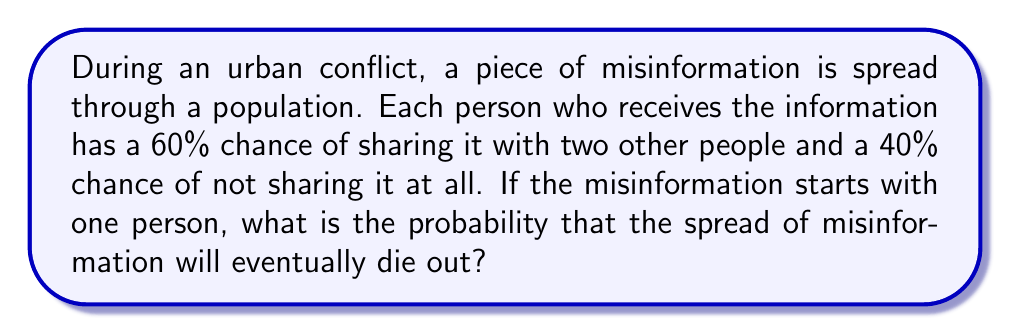Help me with this question. This scenario can be modeled using a branching process. Let's approach this step-by-step:

1) Let $p_0$ be the probability of not sharing (0.4), $p_2$ be the probability of sharing with two people (0.6), and $p_1 = 0$ (as there's no option to share with just one person).

2) The probability generating function (PGF) for this process is:
   $$f(s) = p_0 + p_1s + p_2s^2 = 0.4 + 0.6s^2$$

3) The mean number of "offspring" (people who receive the misinformation from one person) is:
   $$m = f'(1) = 0.6 \cdot 2 = 1.2$$

4) In a branching process, if $m \leq 1$, the process will eventually die out with probability 1. If $m > 1$, there's a positive probability of the process continuing indefinitely.

5) In this case, $m = 1.2 > 1$, so there's a chance the process continues indefinitely. To find the probability of extinction, we need to solve the equation:
   $$s = f(s) = 0.4 + 0.6s^2$$

6) This is equivalent to solving:
   $$0.6s^2 - s + 0.4 = 0$$

7) Using the quadratic formula:
   $$s = \frac{1 \pm \sqrt{1 - 4(0.6)(0.4)}}{2(0.6)} = \frac{1 \pm \sqrt{0.04}}{1.2}$$

8) The smaller root is the probability of extinction:
   $$s = \frac{1 - 0.2}{1.2} = \frac{0.8}{1.2} = \frac{2}{3}$$

Therefore, the probability that the spread of misinformation will eventually die out is $\frac{2}{3}$ or approximately 0.6667.
Answer: $\frac{2}{3}$ 